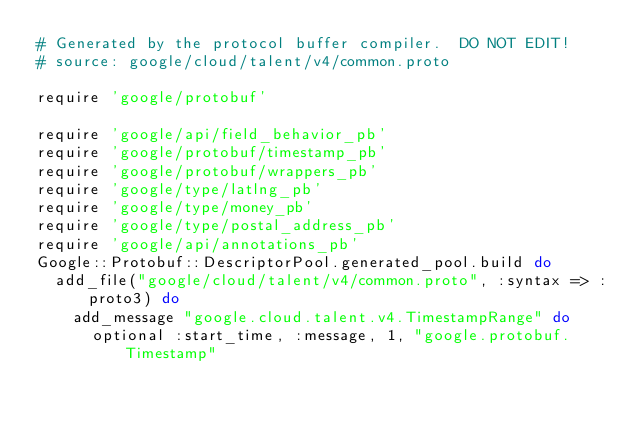<code> <loc_0><loc_0><loc_500><loc_500><_Ruby_># Generated by the protocol buffer compiler.  DO NOT EDIT!
# source: google/cloud/talent/v4/common.proto

require 'google/protobuf'

require 'google/api/field_behavior_pb'
require 'google/protobuf/timestamp_pb'
require 'google/protobuf/wrappers_pb'
require 'google/type/latlng_pb'
require 'google/type/money_pb'
require 'google/type/postal_address_pb'
require 'google/api/annotations_pb'
Google::Protobuf::DescriptorPool.generated_pool.build do
  add_file("google/cloud/talent/v4/common.proto", :syntax => :proto3) do
    add_message "google.cloud.talent.v4.TimestampRange" do
      optional :start_time, :message, 1, "google.protobuf.Timestamp"</code> 